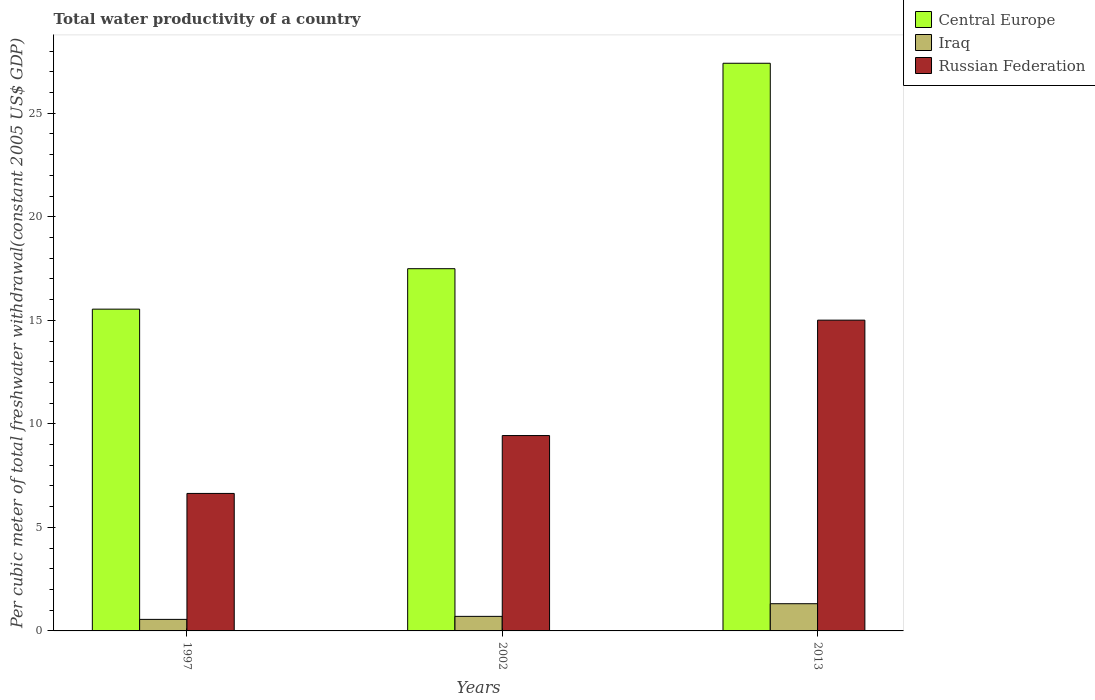How many different coloured bars are there?
Your answer should be compact. 3. What is the label of the 2nd group of bars from the left?
Offer a terse response. 2002. What is the total water productivity in Russian Federation in 2002?
Your response must be concise. 9.43. Across all years, what is the maximum total water productivity in Central Europe?
Provide a short and direct response. 27.41. Across all years, what is the minimum total water productivity in Central Europe?
Your answer should be very brief. 15.54. What is the total total water productivity in Iraq in the graph?
Provide a succinct answer. 2.57. What is the difference between the total water productivity in Iraq in 1997 and that in 2002?
Provide a succinct answer. -0.15. What is the difference between the total water productivity in Iraq in 1997 and the total water productivity in Central Europe in 2002?
Your response must be concise. -16.94. What is the average total water productivity in Iraq per year?
Provide a succinct answer. 0.86. In the year 2013, what is the difference between the total water productivity in Russian Federation and total water productivity in Central Europe?
Your answer should be very brief. -12.41. What is the ratio of the total water productivity in Russian Federation in 2002 to that in 2013?
Your answer should be compact. 0.63. Is the total water productivity in Central Europe in 1997 less than that in 2002?
Give a very brief answer. Yes. What is the difference between the highest and the second highest total water productivity in Russian Federation?
Ensure brevity in your answer.  5.57. What is the difference between the highest and the lowest total water productivity in Iraq?
Your answer should be compact. 0.76. In how many years, is the total water productivity in Iraq greater than the average total water productivity in Iraq taken over all years?
Your answer should be very brief. 1. What does the 2nd bar from the left in 1997 represents?
Your answer should be compact. Iraq. What does the 3rd bar from the right in 1997 represents?
Your response must be concise. Central Europe. Is it the case that in every year, the sum of the total water productivity in Central Europe and total water productivity in Iraq is greater than the total water productivity in Russian Federation?
Offer a very short reply. Yes. Are all the bars in the graph horizontal?
Your answer should be compact. No. What is the difference between two consecutive major ticks on the Y-axis?
Provide a succinct answer. 5. Where does the legend appear in the graph?
Give a very brief answer. Top right. How are the legend labels stacked?
Provide a short and direct response. Vertical. What is the title of the graph?
Give a very brief answer. Total water productivity of a country. What is the label or title of the Y-axis?
Your response must be concise. Per cubic meter of total freshwater withdrawal(constant 2005 US$ GDP). What is the Per cubic meter of total freshwater withdrawal(constant 2005 US$ GDP) of Central Europe in 1997?
Offer a terse response. 15.54. What is the Per cubic meter of total freshwater withdrawal(constant 2005 US$ GDP) of Iraq in 1997?
Make the answer very short. 0.56. What is the Per cubic meter of total freshwater withdrawal(constant 2005 US$ GDP) in Russian Federation in 1997?
Make the answer very short. 6.64. What is the Per cubic meter of total freshwater withdrawal(constant 2005 US$ GDP) in Central Europe in 2002?
Offer a very short reply. 17.49. What is the Per cubic meter of total freshwater withdrawal(constant 2005 US$ GDP) in Iraq in 2002?
Your response must be concise. 0.7. What is the Per cubic meter of total freshwater withdrawal(constant 2005 US$ GDP) of Russian Federation in 2002?
Offer a very short reply. 9.43. What is the Per cubic meter of total freshwater withdrawal(constant 2005 US$ GDP) of Central Europe in 2013?
Offer a terse response. 27.41. What is the Per cubic meter of total freshwater withdrawal(constant 2005 US$ GDP) in Iraq in 2013?
Give a very brief answer. 1.31. What is the Per cubic meter of total freshwater withdrawal(constant 2005 US$ GDP) of Russian Federation in 2013?
Offer a terse response. 15.01. Across all years, what is the maximum Per cubic meter of total freshwater withdrawal(constant 2005 US$ GDP) in Central Europe?
Provide a succinct answer. 27.41. Across all years, what is the maximum Per cubic meter of total freshwater withdrawal(constant 2005 US$ GDP) of Iraq?
Provide a succinct answer. 1.31. Across all years, what is the maximum Per cubic meter of total freshwater withdrawal(constant 2005 US$ GDP) in Russian Federation?
Give a very brief answer. 15.01. Across all years, what is the minimum Per cubic meter of total freshwater withdrawal(constant 2005 US$ GDP) of Central Europe?
Your answer should be very brief. 15.54. Across all years, what is the minimum Per cubic meter of total freshwater withdrawal(constant 2005 US$ GDP) of Iraq?
Provide a succinct answer. 0.56. Across all years, what is the minimum Per cubic meter of total freshwater withdrawal(constant 2005 US$ GDP) of Russian Federation?
Provide a succinct answer. 6.64. What is the total Per cubic meter of total freshwater withdrawal(constant 2005 US$ GDP) of Central Europe in the graph?
Your response must be concise. 60.44. What is the total Per cubic meter of total freshwater withdrawal(constant 2005 US$ GDP) of Iraq in the graph?
Your answer should be compact. 2.57. What is the total Per cubic meter of total freshwater withdrawal(constant 2005 US$ GDP) in Russian Federation in the graph?
Offer a very short reply. 31.08. What is the difference between the Per cubic meter of total freshwater withdrawal(constant 2005 US$ GDP) in Central Europe in 1997 and that in 2002?
Make the answer very short. -1.95. What is the difference between the Per cubic meter of total freshwater withdrawal(constant 2005 US$ GDP) of Iraq in 1997 and that in 2002?
Ensure brevity in your answer.  -0.15. What is the difference between the Per cubic meter of total freshwater withdrawal(constant 2005 US$ GDP) of Russian Federation in 1997 and that in 2002?
Offer a very short reply. -2.79. What is the difference between the Per cubic meter of total freshwater withdrawal(constant 2005 US$ GDP) in Central Europe in 1997 and that in 2013?
Offer a terse response. -11.87. What is the difference between the Per cubic meter of total freshwater withdrawal(constant 2005 US$ GDP) of Iraq in 1997 and that in 2013?
Keep it short and to the point. -0.76. What is the difference between the Per cubic meter of total freshwater withdrawal(constant 2005 US$ GDP) of Russian Federation in 1997 and that in 2013?
Your answer should be compact. -8.37. What is the difference between the Per cubic meter of total freshwater withdrawal(constant 2005 US$ GDP) in Central Europe in 2002 and that in 2013?
Your answer should be very brief. -9.92. What is the difference between the Per cubic meter of total freshwater withdrawal(constant 2005 US$ GDP) of Iraq in 2002 and that in 2013?
Your answer should be very brief. -0.61. What is the difference between the Per cubic meter of total freshwater withdrawal(constant 2005 US$ GDP) of Russian Federation in 2002 and that in 2013?
Provide a short and direct response. -5.57. What is the difference between the Per cubic meter of total freshwater withdrawal(constant 2005 US$ GDP) in Central Europe in 1997 and the Per cubic meter of total freshwater withdrawal(constant 2005 US$ GDP) in Iraq in 2002?
Offer a terse response. 14.84. What is the difference between the Per cubic meter of total freshwater withdrawal(constant 2005 US$ GDP) in Central Europe in 1997 and the Per cubic meter of total freshwater withdrawal(constant 2005 US$ GDP) in Russian Federation in 2002?
Offer a terse response. 6.1. What is the difference between the Per cubic meter of total freshwater withdrawal(constant 2005 US$ GDP) of Iraq in 1997 and the Per cubic meter of total freshwater withdrawal(constant 2005 US$ GDP) of Russian Federation in 2002?
Your response must be concise. -8.88. What is the difference between the Per cubic meter of total freshwater withdrawal(constant 2005 US$ GDP) of Central Europe in 1997 and the Per cubic meter of total freshwater withdrawal(constant 2005 US$ GDP) of Iraq in 2013?
Your answer should be very brief. 14.22. What is the difference between the Per cubic meter of total freshwater withdrawal(constant 2005 US$ GDP) of Central Europe in 1997 and the Per cubic meter of total freshwater withdrawal(constant 2005 US$ GDP) of Russian Federation in 2013?
Make the answer very short. 0.53. What is the difference between the Per cubic meter of total freshwater withdrawal(constant 2005 US$ GDP) of Iraq in 1997 and the Per cubic meter of total freshwater withdrawal(constant 2005 US$ GDP) of Russian Federation in 2013?
Your answer should be very brief. -14.45. What is the difference between the Per cubic meter of total freshwater withdrawal(constant 2005 US$ GDP) in Central Europe in 2002 and the Per cubic meter of total freshwater withdrawal(constant 2005 US$ GDP) in Iraq in 2013?
Offer a terse response. 16.18. What is the difference between the Per cubic meter of total freshwater withdrawal(constant 2005 US$ GDP) of Central Europe in 2002 and the Per cubic meter of total freshwater withdrawal(constant 2005 US$ GDP) of Russian Federation in 2013?
Offer a very short reply. 2.49. What is the difference between the Per cubic meter of total freshwater withdrawal(constant 2005 US$ GDP) in Iraq in 2002 and the Per cubic meter of total freshwater withdrawal(constant 2005 US$ GDP) in Russian Federation in 2013?
Give a very brief answer. -14.3. What is the average Per cubic meter of total freshwater withdrawal(constant 2005 US$ GDP) in Central Europe per year?
Your response must be concise. 20.15. What is the average Per cubic meter of total freshwater withdrawal(constant 2005 US$ GDP) in Iraq per year?
Ensure brevity in your answer.  0.86. What is the average Per cubic meter of total freshwater withdrawal(constant 2005 US$ GDP) of Russian Federation per year?
Ensure brevity in your answer.  10.36. In the year 1997, what is the difference between the Per cubic meter of total freshwater withdrawal(constant 2005 US$ GDP) in Central Europe and Per cubic meter of total freshwater withdrawal(constant 2005 US$ GDP) in Iraq?
Ensure brevity in your answer.  14.98. In the year 1997, what is the difference between the Per cubic meter of total freshwater withdrawal(constant 2005 US$ GDP) of Central Europe and Per cubic meter of total freshwater withdrawal(constant 2005 US$ GDP) of Russian Federation?
Provide a short and direct response. 8.9. In the year 1997, what is the difference between the Per cubic meter of total freshwater withdrawal(constant 2005 US$ GDP) of Iraq and Per cubic meter of total freshwater withdrawal(constant 2005 US$ GDP) of Russian Federation?
Provide a short and direct response. -6.08. In the year 2002, what is the difference between the Per cubic meter of total freshwater withdrawal(constant 2005 US$ GDP) of Central Europe and Per cubic meter of total freshwater withdrawal(constant 2005 US$ GDP) of Iraq?
Ensure brevity in your answer.  16.79. In the year 2002, what is the difference between the Per cubic meter of total freshwater withdrawal(constant 2005 US$ GDP) of Central Europe and Per cubic meter of total freshwater withdrawal(constant 2005 US$ GDP) of Russian Federation?
Your answer should be compact. 8.06. In the year 2002, what is the difference between the Per cubic meter of total freshwater withdrawal(constant 2005 US$ GDP) of Iraq and Per cubic meter of total freshwater withdrawal(constant 2005 US$ GDP) of Russian Federation?
Provide a succinct answer. -8.73. In the year 2013, what is the difference between the Per cubic meter of total freshwater withdrawal(constant 2005 US$ GDP) of Central Europe and Per cubic meter of total freshwater withdrawal(constant 2005 US$ GDP) of Iraq?
Your answer should be very brief. 26.1. In the year 2013, what is the difference between the Per cubic meter of total freshwater withdrawal(constant 2005 US$ GDP) of Central Europe and Per cubic meter of total freshwater withdrawal(constant 2005 US$ GDP) of Russian Federation?
Make the answer very short. 12.41. In the year 2013, what is the difference between the Per cubic meter of total freshwater withdrawal(constant 2005 US$ GDP) of Iraq and Per cubic meter of total freshwater withdrawal(constant 2005 US$ GDP) of Russian Federation?
Keep it short and to the point. -13.69. What is the ratio of the Per cubic meter of total freshwater withdrawal(constant 2005 US$ GDP) of Central Europe in 1997 to that in 2002?
Provide a succinct answer. 0.89. What is the ratio of the Per cubic meter of total freshwater withdrawal(constant 2005 US$ GDP) of Iraq in 1997 to that in 2002?
Offer a terse response. 0.79. What is the ratio of the Per cubic meter of total freshwater withdrawal(constant 2005 US$ GDP) of Russian Federation in 1997 to that in 2002?
Provide a short and direct response. 0.7. What is the ratio of the Per cubic meter of total freshwater withdrawal(constant 2005 US$ GDP) in Central Europe in 1997 to that in 2013?
Offer a very short reply. 0.57. What is the ratio of the Per cubic meter of total freshwater withdrawal(constant 2005 US$ GDP) in Iraq in 1997 to that in 2013?
Offer a very short reply. 0.42. What is the ratio of the Per cubic meter of total freshwater withdrawal(constant 2005 US$ GDP) of Russian Federation in 1997 to that in 2013?
Provide a short and direct response. 0.44. What is the ratio of the Per cubic meter of total freshwater withdrawal(constant 2005 US$ GDP) in Central Europe in 2002 to that in 2013?
Offer a very short reply. 0.64. What is the ratio of the Per cubic meter of total freshwater withdrawal(constant 2005 US$ GDP) of Iraq in 2002 to that in 2013?
Ensure brevity in your answer.  0.54. What is the ratio of the Per cubic meter of total freshwater withdrawal(constant 2005 US$ GDP) in Russian Federation in 2002 to that in 2013?
Provide a succinct answer. 0.63. What is the difference between the highest and the second highest Per cubic meter of total freshwater withdrawal(constant 2005 US$ GDP) of Central Europe?
Keep it short and to the point. 9.92. What is the difference between the highest and the second highest Per cubic meter of total freshwater withdrawal(constant 2005 US$ GDP) of Iraq?
Offer a terse response. 0.61. What is the difference between the highest and the second highest Per cubic meter of total freshwater withdrawal(constant 2005 US$ GDP) in Russian Federation?
Ensure brevity in your answer.  5.57. What is the difference between the highest and the lowest Per cubic meter of total freshwater withdrawal(constant 2005 US$ GDP) in Central Europe?
Provide a succinct answer. 11.87. What is the difference between the highest and the lowest Per cubic meter of total freshwater withdrawal(constant 2005 US$ GDP) in Iraq?
Keep it short and to the point. 0.76. What is the difference between the highest and the lowest Per cubic meter of total freshwater withdrawal(constant 2005 US$ GDP) in Russian Federation?
Ensure brevity in your answer.  8.37. 